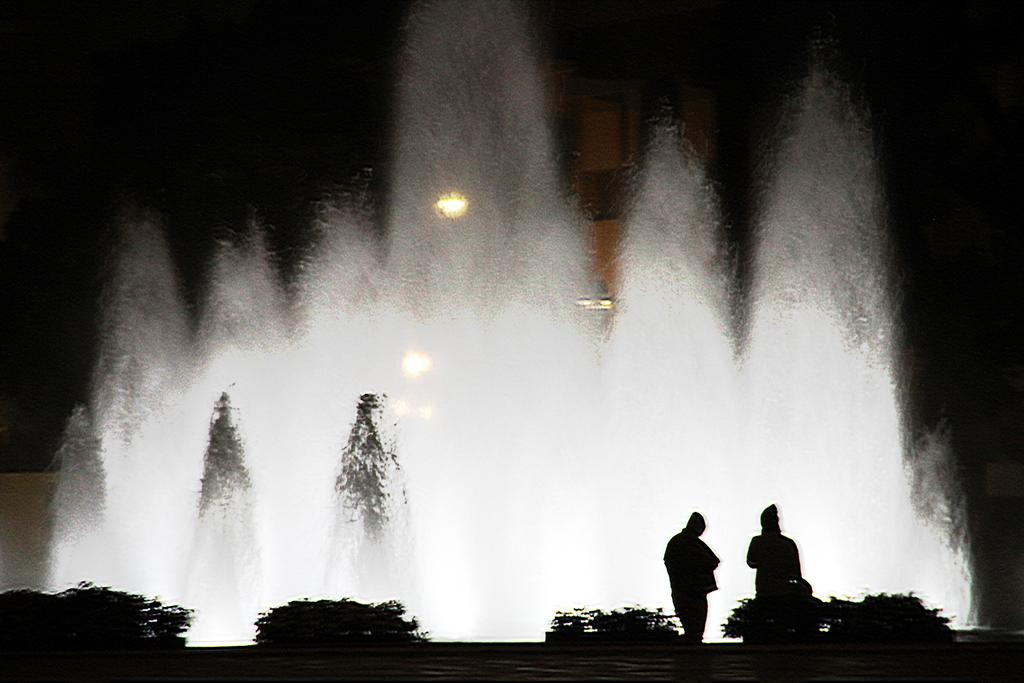How many people are present in the image? There are two persons standing in the image. What can be seen on the ground in the image? There are plants on the ground in the image. What feature is visible in the image that provides water? There is a water fountain visible in the image. What type of illumination is present in the image? There are lights visible in the image. Can you see the horse uses to operate the water fountain in the image? There is no horse or control system present in the image; it features two people, plants, a water fountain, and lights. 